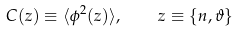<formula> <loc_0><loc_0><loc_500><loc_500>C ( z ) \equiv \langle \phi ^ { 2 } ( z ) \rangle , \quad z \equiv \{ n , \vartheta \}</formula> 